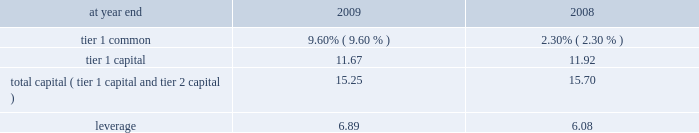Capital resources and liquidity capital resources overview capital has historically been generated by earnings from citi 2019s operating businesses .
Citi may also augment its capital through issuances of common stock , convertible preferred stock , preferred stock , equity issued through awards under employee benefit plans , and , in the case of regulatory capital , through the issuance of subordinated debt underlying trust preferred securities .
In addition , the impact of future events on citi 2019s business results , such as corporate and asset dispositions , as well as changes in accounting standards , also affect citi 2019s capital levels .
Generally , capital is used primarily to support assets in citi 2019s businesses and to absorb market , credit , or operational losses .
While capital may be used for other purposes , such as to pay dividends or repurchase common stock , citi 2019s ability to utilize its capital for these purposes is currently restricted due to its agreements with the u.s .
Government , generally for so long as the u.s .
Government continues to hold citi 2019s common stock or trust preferred securities .
See also 201csupervision and regulation 201d below .
Citigroup 2019s capital management framework is designed to ensure that citigroup and its principal subsidiaries maintain sufficient capital consistent with citi 2019s risk profile and all applicable regulatory standards and guidelines , as well as external rating agency considerations .
The capital management process is centrally overseen by senior management and is reviewed at the consolidated , legal entity , and country level .
Senior management is responsible for the capital management process mainly through citigroup 2019s finance and asset and liability committee ( finalco ) , with oversight from the risk management and finance committee of citigroup 2019s board of directors .
The finalco is composed of the senior-most management of citigroup for the purpose of engaging management in decision-making and related discussions on capital and liquidity matters .
Among other things , finalco 2019s responsibilities include : determining the financial structure of citigroup and its principal subsidiaries ; ensuring that citigroup and its regulated entities are adequately capitalized in consultation with its regulators ; determining appropriate asset levels and return hurdles for citigroup and individual businesses ; reviewing the funding and capital markets plan for citigroup ; and monitoring interest rate risk , corporate and bank liquidity , and the impact of currency translation on non-u.s .
Earnings and capital .
Capital ratios citigroup is subject to the risk-based capital guidelines issued by the federal reserve board .
Historically , capital adequacy has been measured , in part , based on two risk-based capital ratios , the tier 1 capital and total capital ( tier 1 capital + tier 2 capital ) ratios .
Tier 1 capital consists of the sum of 201ccore capital elements , 201d such as qualifying common stockholders 2019 equity , as adjusted , qualifying noncontrolling interests , and qualifying mandatorily redeemable securities of subsidiary trusts , principally reduced by goodwill , other disallowed intangible assets , and disallowed deferred tax assets .
Total capital also includes 201csupplementary 201d tier 2 capital elements , such as qualifying subordinated debt and a limited portion of the allowance for credit losses .
Both measures of capital adequacy are stated as a percentage of risk-weighted assets .
Further , in conjunction with the conduct of the 2009 supervisory capital assessment program ( scap ) , u.s .
Banking regulators developed a new measure of capital termed 201ctier 1 common , 201d which has been defined as tier 1 capital less non-common elements , including qualifying perpetual preferred stock , qualifying noncontrolling interests , and qualifying mandatorily redeemable securities of subsidiary trusts .
Citigroup 2019s risk-weighted assets are principally derived from application of the risk-based capital guidelines related to the measurement of credit risk .
Pursuant to these guidelines , on-balance-sheet assets and the credit equivalent amount of certain off-balance-sheet exposures ( such as financial guarantees , unfunded lending commitments , letters of credit , and derivatives ) are assigned to one of several prescribed risk-weight categories based upon the perceived credit risk associated with the obligor , or if relevant , the guarantor , the nature of the collateral , or external credit ratings .
Risk-weighted assets also incorporate a measure for market risk on covered trading account positions and all foreign exchange and commodity positions whether or not carried in the trading account .
Excluded from risk-weighted assets are any assets , such as goodwill and deferred tax assets , to the extent required to be deducted from regulatory capital .
See 201ccomponents of capital under regulatory guidelines 201d below .
Citigroup is also subject to a leverage ratio requirement , a non-risk-based measure of capital adequacy , which is defined as tier 1 capital as a percentage of quarterly adjusted average total assets .
To be 201cwell capitalized 201d under federal bank regulatory agency definitions , a bank holding company must have a tier 1 capital ratio of at least 6% ( 6 % ) , a total capital ratio of at least 10% ( 10 % ) , and a leverage ratio of at least 3% ( 3 % ) , and not be subject to a federal reserve board directive to maintain higher capital levels .
The table sets forth citigroup 2019s regulatory capital ratios as of december 31 , 2009 and december 31 , 2008 .
Citigroup regulatory capital ratios .
As noted in the table above , citigroup was 201cwell capitalized 201d under the federal bank regulatory agency definitions at year end for both 2009 and 2008. .
What was the change in tier 1 capital ratio between 2008 and 2009? 
Computations: (11.67 - 11.92)
Answer: -0.25. Capital resources and liquidity capital resources overview capital has historically been generated by earnings from citi 2019s operating businesses .
Citi may also augment its capital through issuances of common stock , convertible preferred stock , preferred stock , equity issued through awards under employee benefit plans , and , in the case of regulatory capital , through the issuance of subordinated debt underlying trust preferred securities .
In addition , the impact of future events on citi 2019s business results , such as corporate and asset dispositions , as well as changes in accounting standards , also affect citi 2019s capital levels .
Generally , capital is used primarily to support assets in citi 2019s businesses and to absorb market , credit , or operational losses .
While capital may be used for other purposes , such as to pay dividends or repurchase common stock , citi 2019s ability to utilize its capital for these purposes is currently restricted due to its agreements with the u.s .
Government , generally for so long as the u.s .
Government continues to hold citi 2019s common stock or trust preferred securities .
See also 201csupervision and regulation 201d below .
Citigroup 2019s capital management framework is designed to ensure that citigroup and its principal subsidiaries maintain sufficient capital consistent with citi 2019s risk profile and all applicable regulatory standards and guidelines , as well as external rating agency considerations .
The capital management process is centrally overseen by senior management and is reviewed at the consolidated , legal entity , and country level .
Senior management is responsible for the capital management process mainly through citigroup 2019s finance and asset and liability committee ( finalco ) , with oversight from the risk management and finance committee of citigroup 2019s board of directors .
The finalco is composed of the senior-most management of citigroup for the purpose of engaging management in decision-making and related discussions on capital and liquidity matters .
Among other things , finalco 2019s responsibilities include : determining the financial structure of citigroup and its principal subsidiaries ; ensuring that citigroup and its regulated entities are adequately capitalized in consultation with its regulators ; determining appropriate asset levels and return hurdles for citigroup and individual businesses ; reviewing the funding and capital markets plan for citigroup ; and monitoring interest rate risk , corporate and bank liquidity , and the impact of currency translation on non-u.s .
Earnings and capital .
Capital ratios citigroup is subject to the risk-based capital guidelines issued by the federal reserve board .
Historically , capital adequacy has been measured , in part , based on two risk-based capital ratios , the tier 1 capital and total capital ( tier 1 capital + tier 2 capital ) ratios .
Tier 1 capital consists of the sum of 201ccore capital elements , 201d such as qualifying common stockholders 2019 equity , as adjusted , qualifying noncontrolling interests , and qualifying mandatorily redeemable securities of subsidiary trusts , principally reduced by goodwill , other disallowed intangible assets , and disallowed deferred tax assets .
Total capital also includes 201csupplementary 201d tier 2 capital elements , such as qualifying subordinated debt and a limited portion of the allowance for credit losses .
Both measures of capital adequacy are stated as a percentage of risk-weighted assets .
Further , in conjunction with the conduct of the 2009 supervisory capital assessment program ( scap ) , u.s .
Banking regulators developed a new measure of capital termed 201ctier 1 common , 201d which has been defined as tier 1 capital less non-common elements , including qualifying perpetual preferred stock , qualifying noncontrolling interests , and qualifying mandatorily redeemable securities of subsidiary trusts .
Citigroup 2019s risk-weighted assets are principally derived from application of the risk-based capital guidelines related to the measurement of credit risk .
Pursuant to these guidelines , on-balance-sheet assets and the credit equivalent amount of certain off-balance-sheet exposures ( such as financial guarantees , unfunded lending commitments , letters of credit , and derivatives ) are assigned to one of several prescribed risk-weight categories based upon the perceived credit risk associated with the obligor , or if relevant , the guarantor , the nature of the collateral , or external credit ratings .
Risk-weighted assets also incorporate a measure for market risk on covered trading account positions and all foreign exchange and commodity positions whether or not carried in the trading account .
Excluded from risk-weighted assets are any assets , such as goodwill and deferred tax assets , to the extent required to be deducted from regulatory capital .
See 201ccomponents of capital under regulatory guidelines 201d below .
Citigroup is also subject to a leverage ratio requirement , a non-risk-based measure of capital adequacy , which is defined as tier 1 capital as a percentage of quarterly adjusted average total assets .
To be 201cwell capitalized 201d under federal bank regulatory agency definitions , a bank holding company must have a tier 1 capital ratio of at least 6% ( 6 % ) , a total capital ratio of at least 10% ( 10 % ) , and a leverage ratio of at least 3% ( 3 % ) , and not be subject to a federal reserve board directive to maintain higher capital levels .
The table sets forth citigroup 2019s regulatory capital ratios as of december 31 , 2009 and december 31 , 2008 .
Citigroup regulatory capital ratios .
As noted in the table above , citigroup was 201cwell capitalized 201d under the federal bank regulatory agency definitions at year end for both 2009 and 2008. .
What was the change in tier 1 common ratio between 2008 and 2009? 
Computations: (9.60 - 2.30)
Answer: 7.3. 